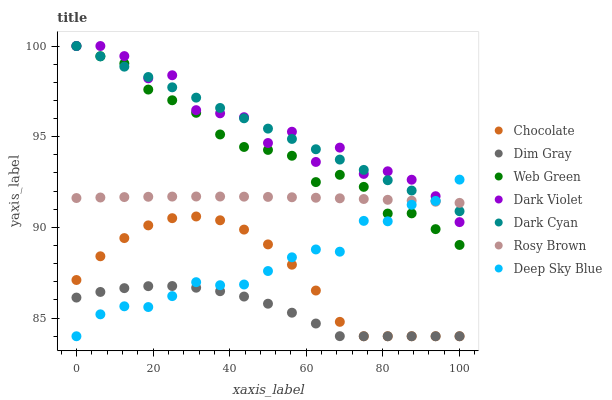Does Dim Gray have the minimum area under the curve?
Answer yes or no. Yes. Does Dark Violet have the maximum area under the curve?
Answer yes or no. Yes. Does Rosy Brown have the minimum area under the curve?
Answer yes or no. No. Does Rosy Brown have the maximum area under the curve?
Answer yes or no. No. Is Dark Cyan the smoothest?
Answer yes or no. Yes. Is Dark Violet the roughest?
Answer yes or no. Yes. Is Rosy Brown the smoothest?
Answer yes or no. No. Is Rosy Brown the roughest?
Answer yes or no. No. Does Dim Gray have the lowest value?
Answer yes or no. Yes. Does Dark Violet have the lowest value?
Answer yes or no. No. Does Dark Cyan have the highest value?
Answer yes or no. Yes. Does Rosy Brown have the highest value?
Answer yes or no. No. Is Chocolate less than Web Green?
Answer yes or no. Yes. Is Web Green greater than Dim Gray?
Answer yes or no. Yes. Does Rosy Brown intersect Web Green?
Answer yes or no. Yes. Is Rosy Brown less than Web Green?
Answer yes or no. No. Is Rosy Brown greater than Web Green?
Answer yes or no. No. Does Chocolate intersect Web Green?
Answer yes or no. No. 